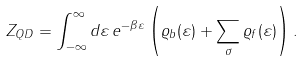Convert formula to latex. <formula><loc_0><loc_0><loc_500><loc_500>Z _ { Q D } = \int ^ { \infty } _ { - \infty } d \varepsilon \, e ^ { - \beta \varepsilon } \left ( \varrho _ { b } ( \varepsilon ) + \sum _ { \sigma } \varrho _ { f } ( \varepsilon ) \right ) .</formula> 